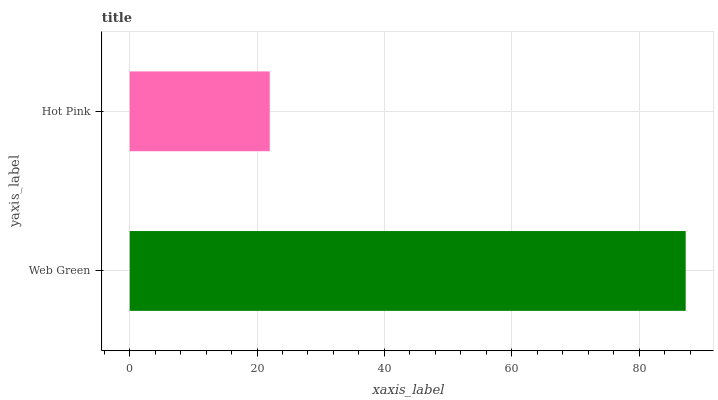Is Hot Pink the minimum?
Answer yes or no. Yes. Is Web Green the maximum?
Answer yes or no. Yes. Is Hot Pink the maximum?
Answer yes or no. No. Is Web Green greater than Hot Pink?
Answer yes or no. Yes. Is Hot Pink less than Web Green?
Answer yes or no. Yes. Is Hot Pink greater than Web Green?
Answer yes or no. No. Is Web Green less than Hot Pink?
Answer yes or no. No. Is Web Green the high median?
Answer yes or no. Yes. Is Hot Pink the low median?
Answer yes or no. Yes. Is Hot Pink the high median?
Answer yes or no. No. Is Web Green the low median?
Answer yes or no. No. 